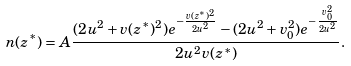<formula> <loc_0><loc_0><loc_500><loc_500>n ( z ^ { \ast } ) = A \frac { ( 2 u ^ { 2 } + v ( z ^ { \ast } ) ^ { 2 } ) e ^ { - \frac { v ( z ^ { \ast } ) ^ { 2 } } { 2 u ^ { 2 } } } - ( 2 u ^ { 2 } + v _ { 0 } ^ { 2 } ) e ^ { - \frac { v _ { 0 } ^ { 2 } } { 2 u ^ { 2 } } } } { 2 u ^ { 2 } v ( z ^ { \ast } ) } .</formula> 